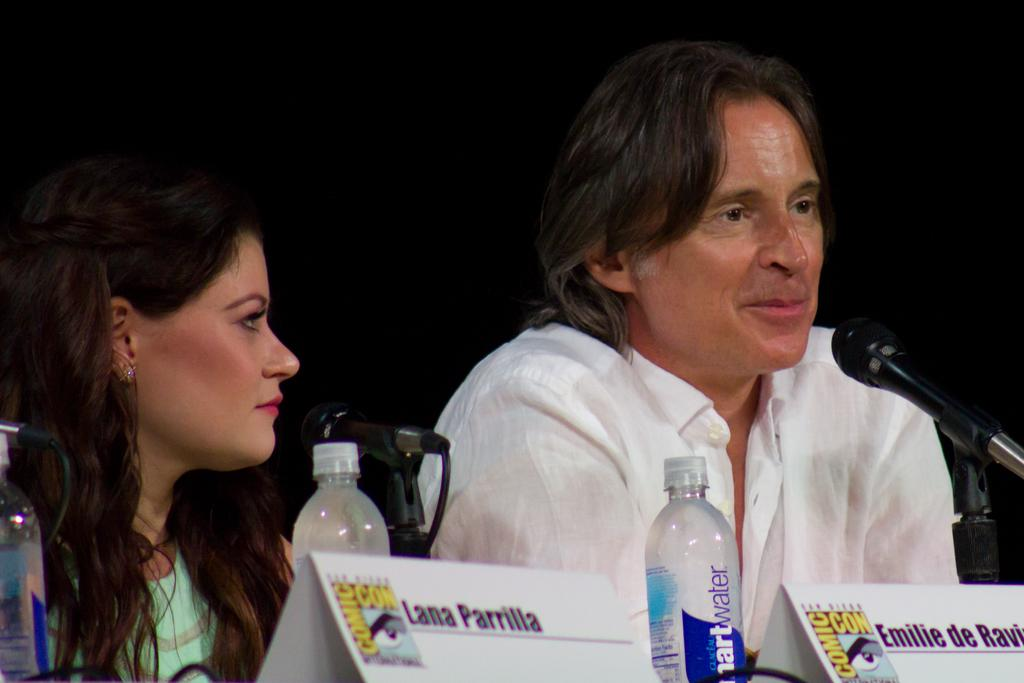What is the man in the image doing? The man is talking on a mic in the image. Who else is present in the image? There is a woman in the image. What object can be seen with the names of people or places? There is a name board in the image. What items are visible for hydration purposes? There are water bottles in the image. What type of teaching method is being demonstrated in the image? There is no teaching method being demonstrated in the image; it only shows a man talking on a mic and a woman present. 